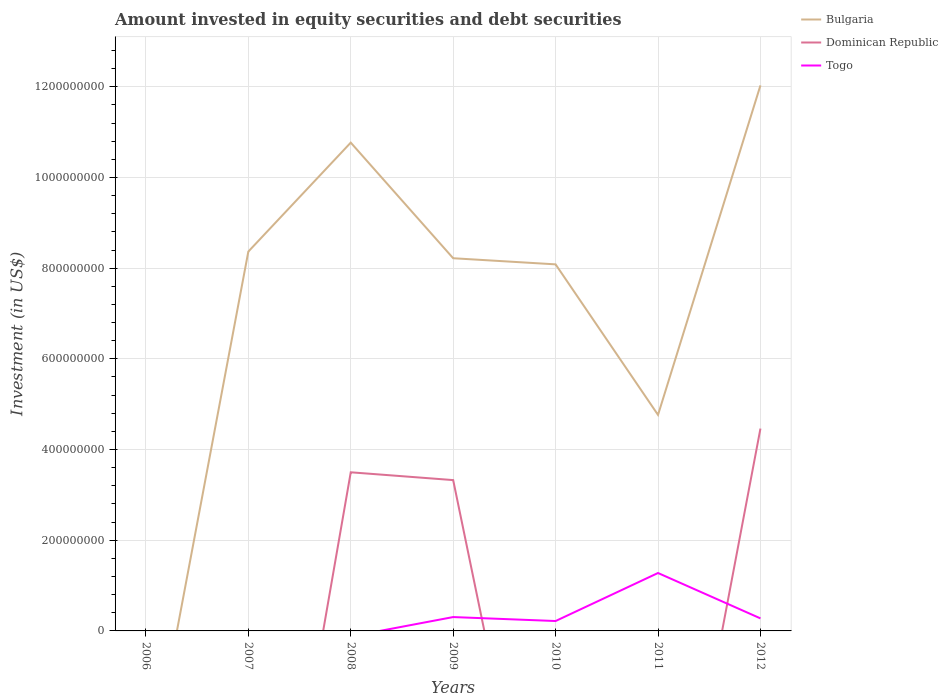How many different coloured lines are there?
Ensure brevity in your answer.  3. Does the line corresponding to Togo intersect with the line corresponding to Bulgaria?
Give a very brief answer. Yes. Is the number of lines equal to the number of legend labels?
Ensure brevity in your answer.  No. What is the total amount invested in equity securities and debt securities in Bulgaria in the graph?
Make the answer very short. 2.55e+08. What is the difference between the highest and the second highest amount invested in equity securities and debt securities in Togo?
Offer a very short reply. 1.28e+08. Is the amount invested in equity securities and debt securities in Dominican Republic strictly greater than the amount invested in equity securities and debt securities in Bulgaria over the years?
Your answer should be very brief. Yes. How many lines are there?
Offer a terse response. 3. How many years are there in the graph?
Provide a succinct answer. 7. Does the graph contain grids?
Give a very brief answer. Yes. How many legend labels are there?
Your answer should be very brief. 3. What is the title of the graph?
Make the answer very short. Amount invested in equity securities and debt securities. What is the label or title of the Y-axis?
Your response must be concise. Investment (in US$). What is the Investment (in US$) in Bulgaria in 2007?
Make the answer very short. 8.37e+08. What is the Investment (in US$) in Dominican Republic in 2007?
Make the answer very short. 0. What is the Investment (in US$) of Togo in 2007?
Your response must be concise. 0. What is the Investment (in US$) of Bulgaria in 2008?
Make the answer very short. 1.08e+09. What is the Investment (in US$) in Dominican Republic in 2008?
Ensure brevity in your answer.  3.50e+08. What is the Investment (in US$) of Bulgaria in 2009?
Keep it short and to the point. 8.22e+08. What is the Investment (in US$) in Dominican Republic in 2009?
Your answer should be compact. 3.33e+08. What is the Investment (in US$) in Togo in 2009?
Keep it short and to the point. 3.06e+07. What is the Investment (in US$) of Bulgaria in 2010?
Ensure brevity in your answer.  8.08e+08. What is the Investment (in US$) in Dominican Republic in 2010?
Keep it short and to the point. 0. What is the Investment (in US$) of Togo in 2010?
Your answer should be compact. 2.18e+07. What is the Investment (in US$) of Bulgaria in 2011?
Offer a terse response. 4.76e+08. What is the Investment (in US$) of Dominican Republic in 2011?
Your answer should be compact. 0. What is the Investment (in US$) of Togo in 2011?
Provide a succinct answer. 1.28e+08. What is the Investment (in US$) of Bulgaria in 2012?
Offer a terse response. 1.20e+09. What is the Investment (in US$) of Dominican Republic in 2012?
Offer a terse response. 4.46e+08. What is the Investment (in US$) of Togo in 2012?
Your response must be concise. 2.76e+07. Across all years, what is the maximum Investment (in US$) in Bulgaria?
Your answer should be very brief. 1.20e+09. Across all years, what is the maximum Investment (in US$) of Dominican Republic?
Offer a terse response. 4.46e+08. Across all years, what is the maximum Investment (in US$) of Togo?
Make the answer very short. 1.28e+08. Across all years, what is the minimum Investment (in US$) of Dominican Republic?
Offer a very short reply. 0. Across all years, what is the minimum Investment (in US$) in Togo?
Keep it short and to the point. 0. What is the total Investment (in US$) in Bulgaria in the graph?
Ensure brevity in your answer.  5.22e+09. What is the total Investment (in US$) of Dominican Republic in the graph?
Your answer should be compact. 1.13e+09. What is the total Investment (in US$) of Togo in the graph?
Your answer should be very brief. 2.08e+08. What is the difference between the Investment (in US$) in Bulgaria in 2007 and that in 2008?
Provide a succinct answer. -2.40e+08. What is the difference between the Investment (in US$) in Bulgaria in 2007 and that in 2009?
Your answer should be compact. 1.47e+07. What is the difference between the Investment (in US$) in Bulgaria in 2007 and that in 2010?
Offer a very short reply. 2.82e+07. What is the difference between the Investment (in US$) of Bulgaria in 2007 and that in 2011?
Give a very brief answer. 3.60e+08. What is the difference between the Investment (in US$) of Bulgaria in 2007 and that in 2012?
Provide a short and direct response. -3.67e+08. What is the difference between the Investment (in US$) of Bulgaria in 2008 and that in 2009?
Offer a terse response. 2.55e+08. What is the difference between the Investment (in US$) in Dominican Republic in 2008 and that in 2009?
Provide a succinct answer. 1.72e+07. What is the difference between the Investment (in US$) in Bulgaria in 2008 and that in 2010?
Offer a terse response. 2.68e+08. What is the difference between the Investment (in US$) of Bulgaria in 2008 and that in 2011?
Provide a short and direct response. 6.00e+08. What is the difference between the Investment (in US$) in Bulgaria in 2008 and that in 2012?
Give a very brief answer. -1.26e+08. What is the difference between the Investment (in US$) in Dominican Republic in 2008 and that in 2012?
Ensure brevity in your answer.  -9.64e+07. What is the difference between the Investment (in US$) in Bulgaria in 2009 and that in 2010?
Keep it short and to the point. 1.35e+07. What is the difference between the Investment (in US$) of Togo in 2009 and that in 2010?
Keep it short and to the point. 8.74e+06. What is the difference between the Investment (in US$) of Bulgaria in 2009 and that in 2011?
Your response must be concise. 3.45e+08. What is the difference between the Investment (in US$) of Togo in 2009 and that in 2011?
Provide a short and direct response. -9.71e+07. What is the difference between the Investment (in US$) of Bulgaria in 2009 and that in 2012?
Your answer should be very brief. -3.81e+08. What is the difference between the Investment (in US$) in Dominican Republic in 2009 and that in 2012?
Ensure brevity in your answer.  -1.14e+08. What is the difference between the Investment (in US$) in Togo in 2009 and that in 2012?
Provide a succinct answer. 2.93e+06. What is the difference between the Investment (in US$) in Bulgaria in 2010 and that in 2011?
Make the answer very short. 3.32e+08. What is the difference between the Investment (in US$) of Togo in 2010 and that in 2011?
Your answer should be very brief. -1.06e+08. What is the difference between the Investment (in US$) in Bulgaria in 2010 and that in 2012?
Your answer should be very brief. -3.95e+08. What is the difference between the Investment (in US$) of Togo in 2010 and that in 2012?
Keep it short and to the point. -5.81e+06. What is the difference between the Investment (in US$) in Bulgaria in 2011 and that in 2012?
Your answer should be very brief. -7.27e+08. What is the difference between the Investment (in US$) of Togo in 2011 and that in 2012?
Provide a short and direct response. 1.00e+08. What is the difference between the Investment (in US$) of Bulgaria in 2007 and the Investment (in US$) of Dominican Republic in 2008?
Your answer should be very brief. 4.87e+08. What is the difference between the Investment (in US$) in Bulgaria in 2007 and the Investment (in US$) in Dominican Republic in 2009?
Your response must be concise. 5.04e+08. What is the difference between the Investment (in US$) in Bulgaria in 2007 and the Investment (in US$) in Togo in 2009?
Provide a short and direct response. 8.06e+08. What is the difference between the Investment (in US$) in Bulgaria in 2007 and the Investment (in US$) in Togo in 2010?
Offer a very short reply. 8.15e+08. What is the difference between the Investment (in US$) of Bulgaria in 2007 and the Investment (in US$) of Togo in 2011?
Keep it short and to the point. 7.09e+08. What is the difference between the Investment (in US$) of Bulgaria in 2007 and the Investment (in US$) of Dominican Republic in 2012?
Offer a very short reply. 3.90e+08. What is the difference between the Investment (in US$) in Bulgaria in 2007 and the Investment (in US$) in Togo in 2012?
Make the answer very short. 8.09e+08. What is the difference between the Investment (in US$) in Bulgaria in 2008 and the Investment (in US$) in Dominican Republic in 2009?
Provide a short and direct response. 7.44e+08. What is the difference between the Investment (in US$) of Bulgaria in 2008 and the Investment (in US$) of Togo in 2009?
Your answer should be compact. 1.05e+09. What is the difference between the Investment (in US$) of Dominican Republic in 2008 and the Investment (in US$) of Togo in 2009?
Provide a short and direct response. 3.19e+08. What is the difference between the Investment (in US$) in Bulgaria in 2008 and the Investment (in US$) in Togo in 2010?
Offer a very short reply. 1.05e+09. What is the difference between the Investment (in US$) in Dominican Republic in 2008 and the Investment (in US$) in Togo in 2010?
Your answer should be compact. 3.28e+08. What is the difference between the Investment (in US$) of Bulgaria in 2008 and the Investment (in US$) of Togo in 2011?
Your answer should be very brief. 9.49e+08. What is the difference between the Investment (in US$) in Dominican Republic in 2008 and the Investment (in US$) in Togo in 2011?
Your response must be concise. 2.22e+08. What is the difference between the Investment (in US$) of Bulgaria in 2008 and the Investment (in US$) of Dominican Republic in 2012?
Ensure brevity in your answer.  6.31e+08. What is the difference between the Investment (in US$) of Bulgaria in 2008 and the Investment (in US$) of Togo in 2012?
Your response must be concise. 1.05e+09. What is the difference between the Investment (in US$) of Dominican Republic in 2008 and the Investment (in US$) of Togo in 2012?
Offer a very short reply. 3.22e+08. What is the difference between the Investment (in US$) in Bulgaria in 2009 and the Investment (in US$) in Togo in 2010?
Your answer should be very brief. 8.00e+08. What is the difference between the Investment (in US$) in Dominican Republic in 2009 and the Investment (in US$) in Togo in 2010?
Give a very brief answer. 3.11e+08. What is the difference between the Investment (in US$) of Bulgaria in 2009 and the Investment (in US$) of Togo in 2011?
Offer a very short reply. 6.94e+08. What is the difference between the Investment (in US$) in Dominican Republic in 2009 and the Investment (in US$) in Togo in 2011?
Offer a terse response. 2.05e+08. What is the difference between the Investment (in US$) of Bulgaria in 2009 and the Investment (in US$) of Dominican Republic in 2012?
Give a very brief answer. 3.76e+08. What is the difference between the Investment (in US$) in Bulgaria in 2009 and the Investment (in US$) in Togo in 2012?
Your response must be concise. 7.94e+08. What is the difference between the Investment (in US$) of Dominican Republic in 2009 and the Investment (in US$) of Togo in 2012?
Provide a short and direct response. 3.05e+08. What is the difference between the Investment (in US$) in Bulgaria in 2010 and the Investment (in US$) in Togo in 2011?
Your response must be concise. 6.81e+08. What is the difference between the Investment (in US$) in Bulgaria in 2010 and the Investment (in US$) in Dominican Republic in 2012?
Give a very brief answer. 3.62e+08. What is the difference between the Investment (in US$) of Bulgaria in 2010 and the Investment (in US$) of Togo in 2012?
Make the answer very short. 7.81e+08. What is the difference between the Investment (in US$) in Bulgaria in 2011 and the Investment (in US$) in Dominican Republic in 2012?
Keep it short and to the point. 3.02e+07. What is the difference between the Investment (in US$) of Bulgaria in 2011 and the Investment (in US$) of Togo in 2012?
Your response must be concise. 4.49e+08. What is the average Investment (in US$) of Bulgaria per year?
Your answer should be compact. 7.46e+08. What is the average Investment (in US$) of Dominican Republic per year?
Offer a terse response. 1.61e+08. What is the average Investment (in US$) in Togo per year?
Provide a succinct answer. 2.97e+07. In the year 2008, what is the difference between the Investment (in US$) of Bulgaria and Investment (in US$) of Dominican Republic?
Provide a short and direct response. 7.27e+08. In the year 2009, what is the difference between the Investment (in US$) of Bulgaria and Investment (in US$) of Dominican Republic?
Offer a terse response. 4.89e+08. In the year 2009, what is the difference between the Investment (in US$) of Bulgaria and Investment (in US$) of Togo?
Your answer should be compact. 7.91e+08. In the year 2009, what is the difference between the Investment (in US$) of Dominican Republic and Investment (in US$) of Togo?
Give a very brief answer. 3.02e+08. In the year 2010, what is the difference between the Investment (in US$) in Bulgaria and Investment (in US$) in Togo?
Offer a terse response. 7.87e+08. In the year 2011, what is the difference between the Investment (in US$) of Bulgaria and Investment (in US$) of Togo?
Give a very brief answer. 3.49e+08. In the year 2012, what is the difference between the Investment (in US$) in Bulgaria and Investment (in US$) in Dominican Republic?
Your answer should be very brief. 7.57e+08. In the year 2012, what is the difference between the Investment (in US$) of Bulgaria and Investment (in US$) of Togo?
Keep it short and to the point. 1.18e+09. In the year 2012, what is the difference between the Investment (in US$) in Dominican Republic and Investment (in US$) in Togo?
Offer a very short reply. 4.19e+08. What is the ratio of the Investment (in US$) of Bulgaria in 2007 to that in 2008?
Make the answer very short. 0.78. What is the ratio of the Investment (in US$) in Bulgaria in 2007 to that in 2009?
Provide a succinct answer. 1.02. What is the ratio of the Investment (in US$) of Bulgaria in 2007 to that in 2010?
Make the answer very short. 1.03. What is the ratio of the Investment (in US$) in Bulgaria in 2007 to that in 2011?
Give a very brief answer. 1.76. What is the ratio of the Investment (in US$) in Bulgaria in 2007 to that in 2012?
Your response must be concise. 0.7. What is the ratio of the Investment (in US$) of Bulgaria in 2008 to that in 2009?
Offer a very short reply. 1.31. What is the ratio of the Investment (in US$) in Dominican Republic in 2008 to that in 2009?
Offer a very short reply. 1.05. What is the ratio of the Investment (in US$) of Bulgaria in 2008 to that in 2010?
Your response must be concise. 1.33. What is the ratio of the Investment (in US$) of Bulgaria in 2008 to that in 2011?
Your answer should be compact. 2.26. What is the ratio of the Investment (in US$) of Bulgaria in 2008 to that in 2012?
Your answer should be very brief. 0.9. What is the ratio of the Investment (in US$) of Dominican Republic in 2008 to that in 2012?
Offer a very short reply. 0.78. What is the ratio of the Investment (in US$) in Bulgaria in 2009 to that in 2010?
Ensure brevity in your answer.  1.02. What is the ratio of the Investment (in US$) of Togo in 2009 to that in 2010?
Ensure brevity in your answer.  1.4. What is the ratio of the Investment (in US$) in Bulgaria in 2009 to that in 2011?
Make the answer very short. 1.73. What is the ratio of the Investment (in US$) of Togo in 2009 to that in 2011?
Provide a short and direct response. 0.24. What is the ratio of the Investment (in US$) in Bulgaria in 2009 to that in 2012?
Ensure brevity in your answer.  0.68. What is the ratio of the Investment (in US$) of Dominican Republic in 2009 to that in 2012?
Provide a short and direct response. 0.75. What is the ratio of the Investment (in US$) in Togo in 2009 to that in 2012?
Provide a succinct answer. 1.11. What is the ratio of the Investment (in US$) in Bulgaria in 2010 to that in 2011?
Provide a short and direct response. 1.7. What is the ratio of the Investment (in US$) of Togo in 2010 to that in 2011?
Ensure brevity in your answer.  0.17. What is the ratio of the Investment (in US$) of Bulgaria in 2010 to that in 2012?
Your answer should be compact. 0.67. What is the ratio of the Investment (in US$) of Togo in 2010 to that in 2012?
Offer a terse response. 0.79. What is the ratio of the Investment (in US$) in Bulgaria in 2011 to that in 2012?
Offer a terse response. 0.4. What is the ratio of the Investment (in US$) in Togo in 2011 to that in 2012?
Ensure brevity in your answer.  4.62. What is the difference between the highest and the second highest Investment (in US$) of Bulgaria?
Provide a succinct answer. 1.26e+08. What is the difference between the highest and the second highest Investment (in US$) in Dominican Republic?
Make the answer very short. 9.64e+07. What is the difference between the highest and the second highest Investment (in US$) of Togo?
Your answer should be compact. 9.71e+07. What is the difference between the highest and the lowest Investment (in US$) in Bulgaria?
Ensure brevity in your answer.  1.20e+09. What is the difference between the highest and the lowest Investment (in US$) in Dominican Republic?
Your answer should be compact. 4.46e+08. What is the difference between the highest and the lowest Investment (in US$) in Togo?
Keep it short and to the point. 1.28e+08. 